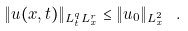Convert formula to latex. <formula><loc_0><loc_0><loc_500><loc_500>\| u ( x , t ) \| _ { L ^ { q } _ { t } L ^ { r } _ { x } } \leq \| u _ { 0 } \| _ { L ^ { 2 } _ { x } } \ .</formula> 